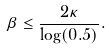<formula> <loc_0><loc_0><loc_500><loc_500>\beta \leq \frac { 2 \kappa } { \log ( 0 . 5 ) } .</formula> 